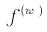Convert formula to latex. <formula><loc_0><loc_0><loc_500><loc_500>f ^ { ( w _ { j } ) }</formula> 